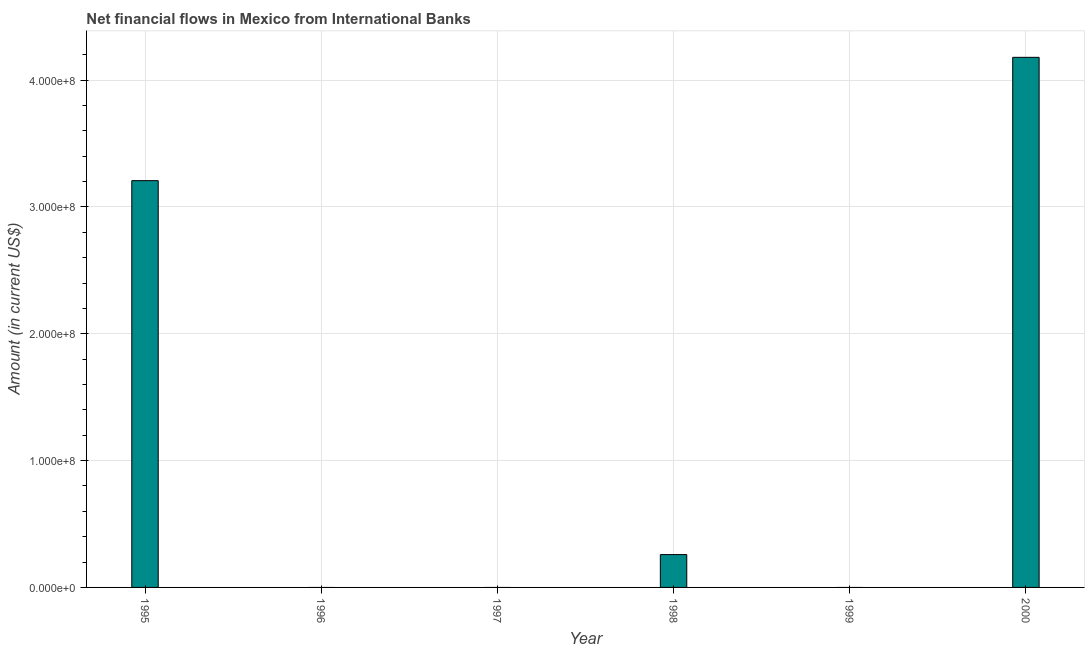Does the graph contain any zero values?
Provide a short and direct response. Yes. What is the title of the graph?
Make the answer very short. Net financial flows in Mexico from International Banks. What is the label or title of the X-axis?
Ensure brevity in your answer.  Year. Across all years, what is the maximum net financial flows from ibrd?
Make the answer very short. 4.18e+08. Across all years, what is the minimum net financial flows from ibrd?
Provide a short and direct response. 0. In which year was the net financial flows from ibrd maximum?
Offer a terse response. 2000. What is the sum of the net financial flows from ibrd?
Your response must be concise. 7.65e+08. What is the difference between the net financial flows from ibrd in 1995 and 1998?
Offer a terse response. 2.95e+08. What is the average net financial flows from ibrd per year?
Your answer should be compact. 1.27e+08. What is the median net financial flows from ibrd?
Your response must be concise. 1.29e+07. In how many years, is the net financial flows from ibrd greater than 380000000 US$?
Your response must be concise. 1. What is the ratio of the net financial flows from ibrd in 1995 to that in 2000?
Your response must be concise. 0.77. Is the net financial flows from ibrd in 1995 less than that in 1998?
Your answer should be compact. No. What is the difference between the highest and the second highest net financial flows from ibrd?
Offer a terse response. 9.72e+07. Is the sum of the net financial flows from ibrd in 1995 and 1998 greater than the maximum net financial flows from ibrd across all years?
Your response must be concise. No. What is the difference between the highest and the lowest net financial flows from ibrd?
Give a very brief answer. 4.18e+08. What is the difference between two consecutive major ticks on the Y-axis?
Make the answer very short. 1.00e+08. What is the Amount (in current US$) in 1995?
Ensure brevity in your answer.  3.21e+08. What is the Amount (in current US$) in 1998?
Provide a short and direct response. 2.59e+07. What is the Amount (in current US$) in 1999?
Give a very brief answer. 0. What is the Amount (in current US$) of 2000?
Give a very brief answer. 4.18e+08. What is the difference between the Amount (in current US$) in 1995 and 1998?
Ensure brevity in your answer.  2.95e+08. What is the difference between the Amount (in current US$) in 1995 and 2000?
Keep it short and to the point. -9.72e+07. What is the difference between the Amount (in current US$) in 1998 and 2000?
Offer a very short reply. -3.92e+08. What is the ratio of the Amount (in current US$) in 1995 to that in 1998?
Provide a succinct answer. 12.38. What is the ratio of the Amount (in current US$) in 1995 to that in 2000?
Your answer should be very brief. 0.77. What is the ratio of the Amount (in current US$) in 1998 to that in 2000?
Make the answer very short. 0.06. 